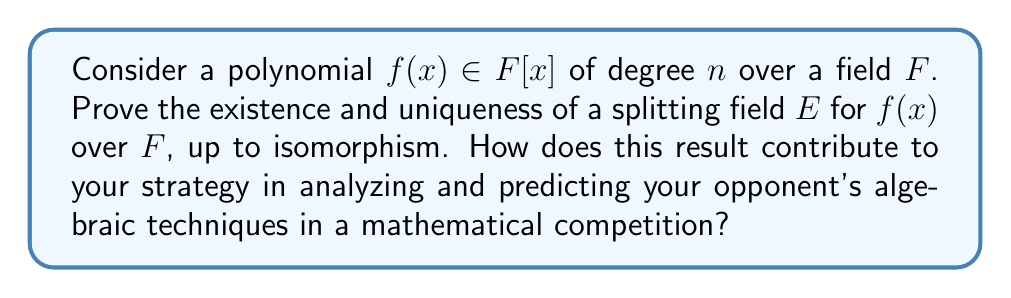Can you solve this math problem? 1) Existence:
   a) Start with $F$ and adjoin a root $\alpha_1$ of $f(x)$ to get $F(\alpha_1)$.
   b) Factor $f(x)$ in $F(\alpha_1)[x]$ and repeat the process with any irreducible factors.
   c) After at most $n$ steps, we obtain a field $E = F(\alpha_1, \alpha_2, ..., \alpha_k)$ where $f(x)$ splits completely.

2) Uniqueness (up to isomorphism):
   a) Let $E$ and $E'$ be two splitting fields for $f(x)$ over $F$.
   b) Define $\phi_0: F \to F$ as the identity map.
   c) Extend $\phi_0$ to $\phi_1: F(\alpha_1) \to E'$ by mapping $\alpha_1$ to a root of $f(x)$ in $E'$.
   d) Continue this process, extending $\phi_i$ to $\phi_{i+1}$ at each step.
   e) After $k$ steps, we have an isomorphism $\phi: E \to E'$.

3) Uniqueness of the extension:
   The choice of roots at each step might seem arbitrary, but any such choice leads to an isomorphic field.

4) Competition strategy:
   Understanding splitting fields allows you to:
   a) Predict how your opponent might approach problems involving field extensions.
   b) Recognize when a problem can be solved by considering the splitting field.
   c) Efficiently construct minimal fields containing all roots of a given polynomial.

5) Key aspects for competitive advantage:
   a) Splitting fields provide a "universal" solution for polynomial factorization.
   b) They are minimal, containing exactly what's needed to split the polynomial.
   c) The uniqueness (up to isomorphism) ensures that any correct approach will lead to equivalent results.
Answer: Splitting fields exist and are unique up to isomorphism for any polynomial over a field. 